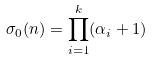<formula> <loc_0><loc_0><loc_500><loc_500>\sigma _ { 0 } ( n ) = \prod _ { i = 1 } ^ { k } ( \alpha _ { i } + 1 )</formula> 